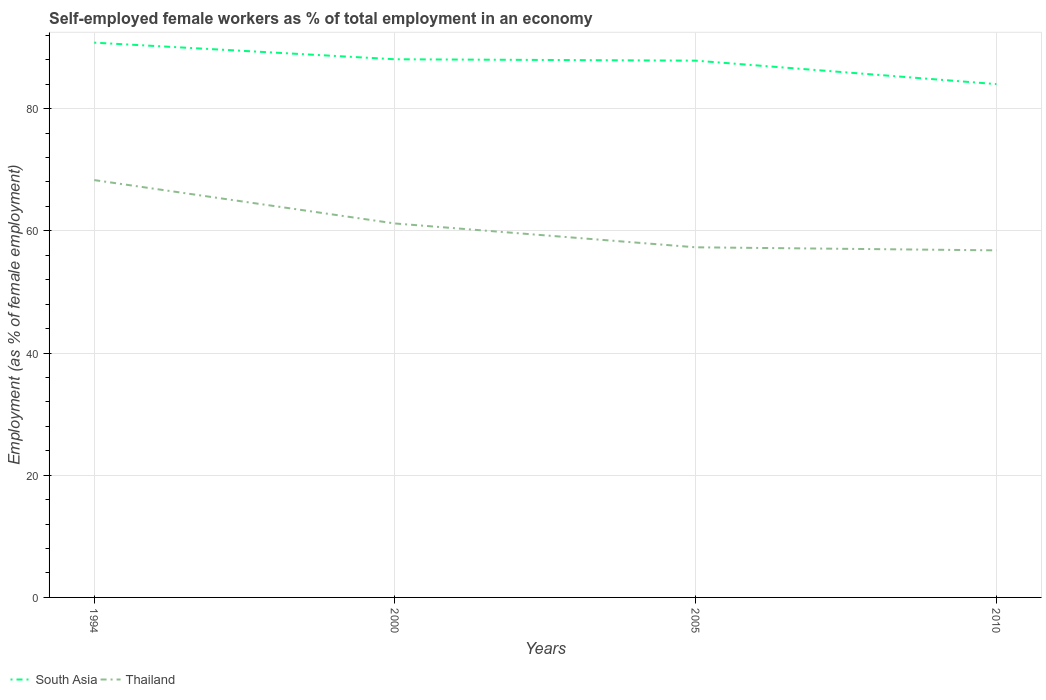How many different coloured lines are there?
Your answer should be compact. 2. Across all years, what is the maximum percentage of self-employed female workers in Thailand?
Provide a succinct answer. 56.8. What is the total percentage of self-employed female workers in Thailand in the graph?
Give a very brief answer. 11.5. What is the difference between the highest and the second highest percentage of self-employed female workers in South Asia?
Your answer should be compact. 6.79. Is the percentage of self-employed female workers in Thailand strictly greater than the percentage of self-employed female workers in South Asia over the years?
Provide a short and direct response. Yes. How many years are there in the graph?
Give a very brief answer. 4. Does the graph contain any zero values?
Offer a very short reply. No. Does the graph contain grids?
Make the answer very short. Yes. Where does the legend appear in the graph?
Your answer should be very brief. Bottom left. What is the title of the graph?
Your response must be concise. Self-employed female workers as % of total employment in an economy. Does "West Bank and Gaza" appear as one of the legend labels in the graph?
Offer a very short reply. No. What is the label or title of the Y-axis?
Your response must be concise. Employment (as % of female employment). What is the Employment (as % of female employment) in South Asia in 1994?
Your answer should be compact. 90.79. What is the Employment (as % of female employment) of Thailand in 1994?
Your answer should be very brief. 68.3. What is the Employment (as % of female employment) in South Asia in 2000?
Make the answer very short. 88.07. What is the Employment (as % of female employment) in Thailand in 2000?
Offer a terse response. 61.2. What is the Employment (as % of female employment) in South Asia in 2005?
Keep it short and to the point. 87.85. What is the Employment (as % of female employment) in Thailand in 2005?
Give a very brief answer. 57.3. What is the Employment (as % of female employment) in South Asia in 2010?
Offer a very short reply. 84.01. What is the Employment (as % of female employment) in Thailand in 2010?
Your response must be concise. 56.8. Across all years, what is the maximum Employment (as % of female employment) of South Asia?
Make the answer very short. 90.79. Across all years, what is the maximum Employment (as % of female employment) of Thailand?
Offer a terse response. 68.3. Across all years, what is the minimum Employment (as % of female employment) in South Asia?
Your answer should be very brief. 84.01. Across all years, what is the minimum Employment (as % of female employment) of Thailand?
Your answer should be compact. 56.8. What is the total Employment (as % of female employment) in South Asia in the graph?
Provide a succinct answer. 350.72. What is the total Employment (as % of female employment) in Thailand in the graph?
Make the answer very short. 243.6. What is the difference between the Employment (as % of female employment) in South Asia in 1994 and that in 2000?
Keep it short and to the point. 2.72. What is the difference between the Employment (as % of female employment) of Thailand in 1994 and that in 2000?
Make the answer very short. 7.1. What is the difference between the Employment (as % of female employment) of South Asia in 1994 and that in 2005?
Make the answer very short. 2.95. What is the difference between the Employment (as % of female employment) in Thailand in 1994 and that in 2005?
Your answer should be compact. 11. What is the difference between the Employment (as % of female employment) of South Asia in 1994 and that in 2010?
Ensure brevity in your answer.  6.79. What is the difference between the Employment (as % of female employment) of Thailand in 1994 and that in 2010?
Provide a succinct answer. 11.5. What is the difference between the Employment (as % of female employment) of South Asia in 2000 and that in 2005?
Your answer should be compact. 0.22. What is the difference between the Employment (as % of female employment) in Thailand in 2000 and that in 2005?
Your response must be concise. 3.9. What is the difference between the Employment (as % of female employment) of South Asia in 2000 and that in 2010?
Give a very brief answer. 4.07. What is the difference between the Employment (as % of female employment) of Thailand in 2000 and that in 2010?
Offer a very short reply. 4.4. What is the difference between the Employment (as % of female employment) of South Asia in 2005 and that in 2010?
Make the answer very short. 3.84. What is the difference between the Employment (as % of female employment) of South Asia in 1994 and the Employment (as % of female employment) of Thailand in 2000?
Make the answer very short. 29.59. What is the difference between the Employment (as % of female employment) in South Asia in 1994 and the Employment (as % of female employment) in Thailand in 2005?
Your answer should be compact. 33.49. What is the difference between the Employment (as % of female employment) in South Asia in 1994 and the Employment (as % of female employment) in Thailand in 2010?
Keep it short and to the point. 33.99. What is the difference between the Employment (as % of female employment) in South Asia in 2000 and the Employment (as % of female employment) in Thailand in 2005?
Offer a terse response. 30.77. What is the difference between the Employment (as % of female employment) in South Asia in 2000 and the Employment (as % of female employment) in Thailand in 2010?
Provide a short and direct response. 31.27. What is the difference between the Employment (as % of female employment) in South Asia in 2005 and the Employment (as % of female employment) in Thailand in 2010?
Provide a succinct answer. 31.05. What is the average Employment (as % of female employment) of South Asia per year?
Keep it short and to the point. 87.68. What is the average Employment (as % of female employment) of Thailand per year?
Ensure brevity in your answer.  60.9. In the year 1994, what is the difference between the Employment (as % of female employment) in South Asia and Employment (as % of female employment) in Thailand?
Provide a succinct answer. 22.49. In the year 2000, what is the difference between the Employment (as % of female employment) of South Asia and Employment (as % of female employment) of Thailand?
Make the answer very short. 26.87. In the year 2005, what is the difference between the Employment (as % of female employment) of South Asia and Employment (as % of female employment) of Thailand?
Your answer should be compact. 30.55. In the year 2010, what is the difference between the Employment (as % of female employment) in South Asia and Employment (as % of female employment) in Thailand?
Provide a succinct answer. 27.21. What is the ratio of the Employment (as % of female employment) in South Asia in 1994 to that in 2000?
Keep it short and to the point. 1.03. What is the ratio of the Employment (as % of female employment) of Thailand in 1994 to that in 2000?
Make the answer very short. 1.12. What is the ratio of the Employment (as % of female employment) in South Asia in 1994 to that in 2005?
Ensure brevity in your answer.  1.03. What is the ratio of the Employment (as % of female employment) in Thailand in 1994 to that in 2005?
Offer a terse response. 1.19. What is the ratio of the Employment (as % of female employment) in South Asia in 1994 to that in 2010?
Keep it short and to the point. 1.08. What is the ratio of the Employment (as % of female employment) of Thailand in 1994 to that in 2010?
Ensure brevity in your answer.  1.2. What is the ratio of the Employment (as % of female employment) of South Asia in 2000 to that in 2005?
Offer a terse response. 1. What is the ratio of the Employment (as % of female employment) of Thailand in 2000 to that in 2005?
Offer a very short reply. 1.07. What is the ratio of the Employment (as % of female employment) of South Asia in 2000 to that in 2010?
Ensure brevity in your answer.  1.05. What is the ratio of the Employment (as % of female employment) of Thailand in 2000 to that in 2010?
Provide a succinct answer. 1.08. What is the ratio of the Employment (as % of female employment) in South Asia in 2005 to that in 2010?
Keep it short and to the point. 1.05. What is the ratio of the Employment (as % of female employment) in Thailand in 2005 to that in 2010?
Provide a succinct answer. 1.01. What is the difference between the highest and the second highest Employment (as % of female employment) in South Asia?
Keep it short and to the point. 2.72. What is the difference between the highest and the second highest Employment (as % of female employment) of Thailand?
Give a very brief answer. 7.1. What is the difference between the highest and the lowest Employment (as % of female employment) of South Asia?
Your response must be concise. 6.79. What is the difference between the highest and the lowest Employment (as % of female employment) of Thailand?
Ensure brevity in your answer.  11.5. 